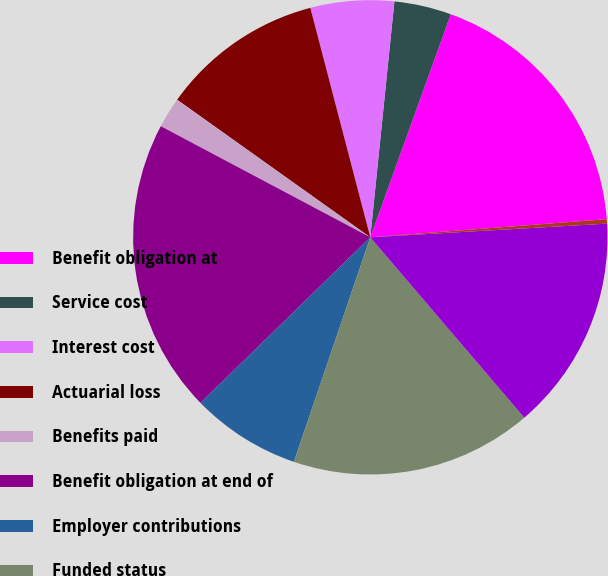Convert chart. <chart><loc_0><loc_0><loc_500><loc_500><pie_chart><fcel>Benefit obligation at<fcel>Service cost<fcel>Interest cost<fcel>Actuarial loss<fcel>Benefits paid<fcel>Benefit obligation at end of<fcel>Employer contributions<fcel>Funded status<fcel>Unrecognized net actuarial<fcel>Unrecognized prior service<nl><fcel>18.27%<fcel>3.89%<fcel>5.69%<fcel>11.08%<fcel>2.09%<fcel>20.06%<fcel>7.48%<fcel>16.47%<fcel>14.67%<fcel>0.3%<nl></chart> 